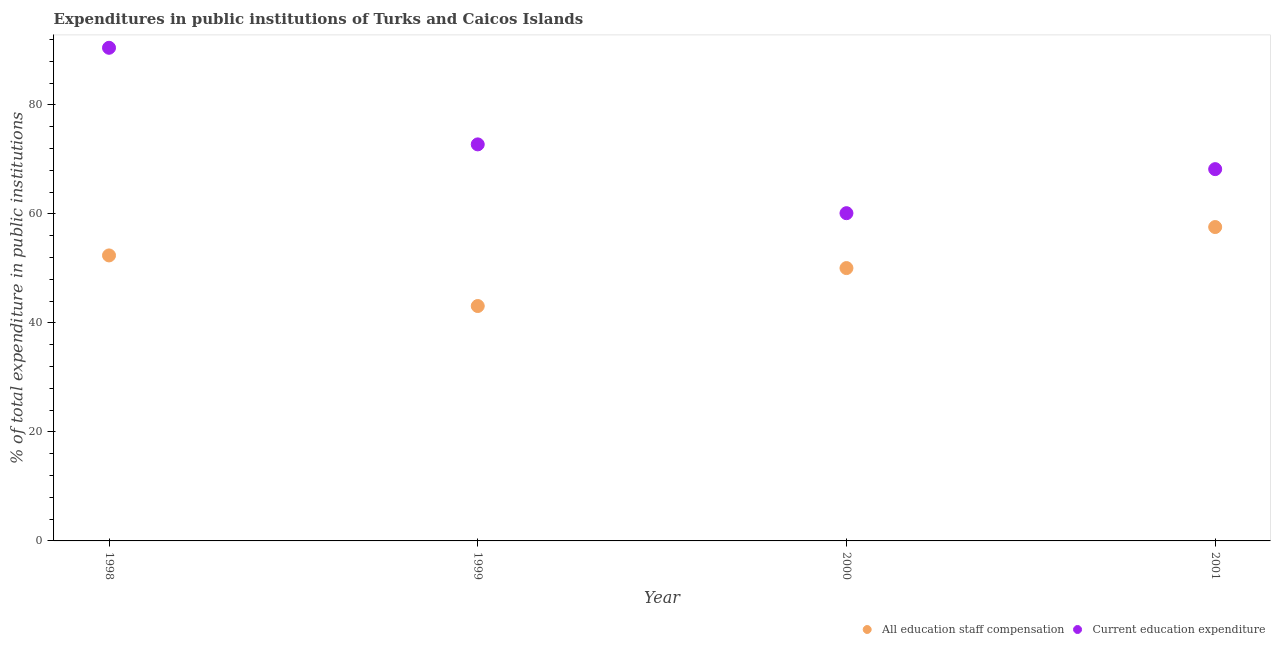What is the expenditure in education in 1998?
Offer a terse response. 90.48. Across all years, what is the maximum expenditure in education?
Make the answer very short. 90.48. Across all years, what is the minimum expenditure in education?
Keep it short and to the point. 60.13. In which year was the expenditure in staff compensation minimum?
Offer a terse response. 1999. What is the total expenditure in education in the graph?
Offer a terse response. 291.57. What is the difference between the expenditure in education in 1999 and that in 2001?
Offer a very short reply. 4.54. What is the difference between the expenditure in education in 1999 and the expenditure in staff compensation in 1998?
Give a very brief answer. 20.37. What is the average expenditure in staff compensation per year?
Your answer should be very brief. 50.78. In the year 1999, what is the difference between the expenditure in education and expenditure in staff compensation?
Give a very brief answer. 29.66. What is the ratio of the expenditure in education in 1998 to that in 1999?
Provide a succinct answer. 1.24. Is the difference between the expenditure in education in 2000 and 2001 greater than the difference between the expenditure in staff compensation in 2000 and 2001?
Your answer should be compact. No. What is the difference between the highest and the second highest expenditure in education?
Your answer should be compact. 17.72. What is the difference between the highest and the lowest expenditure in staff compensation?
Your answer should be compact. 14.49. Is the sum of the expenditure in staff compensation in 2000 and 2001 greater than the maximum expenditure in education across all years?
Provide a succinct answer. Yes. Is the expenditure in education strictly greater than the expenditure in staff compensation over the years?
Keep it short and to the point. Yes. What is the difference between two consecutive major ticks on the Y-axis?
Offer a very short reply. 20. Does the graph contain any zero values?
Keep it short and to the point. No. How many legend labels are there?
Offer a terse response. 2. How are the legend labels stacked?
Your answer should be compact. Horizontal. What is the title of the graph?
Your response must be concise. Expenditures in public institutions of Turks and Caicos Islands. What is the label or title of the X-axis?
Keep it short and to the point. Year. What is the label or title of the Y-axis?
Provide a succinct answer. % of total expenditure in public institutions. What is the % of total expenditure in public institutions of All education staff compensation in 1998?
Your answer should be very brief. 52.38. What is the % of total expenditure in public institutions of Current education expenditure in 1998?
Make the answer very short. 90.48. What is the % of total expenditure in public institutions of All education staff compensation in 1999?
Ensure brevity in your answer.  43.1. What is the % of total expenditure in public institutions in Current education expenditure in 1999?
Give a very brief answer. 72.75. What is the % of total expenditure in public institutions of All education staff compensation in 2000?
Provide a succinct answer. 50.06. What is the % of total expenditure in public institutions in Current education expenditure in 2000?
Give a very brief answer. 60.13. What is the % of total expenditure in public institutions in All education staff compensation in 2001?
Your response must be concise. 57.59. What is the % of total expenditure in public institutions of Current education expenditure in 2001?
Your answer should be very brief. 68.21. Across all years, what is the maximum % of total expenditure in public institutions in All education staff compensation?
Your response must be concise. 57.59. Across all years, what is the maximum % of total expenditure in public institutions of Current education expenditure?
Ensure brevity in your answer.  90.48. Across all years, what is the minimum % of total expenditure in public institutions in All education staff compensation?
Give a very brief answer. 43.1. Across all years, what is the minimum % of total expenditure in public institutions in Current education expenditure?
Offer a very short reply. 60.13. What is the total % of total expenditure in public institutions of All education staff compensation in the graph?
Your response must be concise. 203.12. What is the total % of total expenditure in public institutions of Current education expenditure in the graph?
Keep it short and to the point. 291.57. What is the difference between the % of total expenditure in public institutions in All education staff compensation in 1998 and that in 1999?
Ensure brevity in your answer.  9.28. What is the difference between the % of total expenditure in public institutions of Current education expenditure in 1998 and that in 1999?
Provide a succinct answer. 17.72. What is the difference between the % of total expenditure in public institutions of All education staff compensation in 1998 and that in 2000?
Make the answer very short. 2.32. What is the difference between the % of total expenditure in public institutions of Current education expenditure in 1998 and that in 2000?
Provide a short and direct response. 30.35. What is the difference between the % of total expenditure in public institutions of All education staff compensation in 1998 and that in 2001?
Offer a terse response. -5.21. What is the difference between the % of total expenditure in public institutions in Current education expenditure in 1998 and that in 2001?
Make the answer very short. 22.26. What is the difference between the % of total expenditure in public institutions of All education staff compensation in 1999 and that in 2000?
Your answer should be compact. -6.96. What is the difference between the % of total expenditure in public institutions of Current education expenditure in 1999 and that in 2000?
Keep it short and to the point. 12.62. What is the difference between the % of total expenditure in public institutions of All education staff compensation in 1999 and that in 2001?
Ensure brevity in your answer.  -14.49. What is the difference between the % of total expenditure in public institutions of Current education expenditure in 1999 and that in 2001?
Ensure brevity in your answer.  4.54. What is the difference between the % of total expenditure in public institutions of All education staff compensation in 2000 and that in 2001?
Make the answer very short. -7.53. What is the difference between the % of total expenditure in public institutions of Current education expenditure in 2000 and that in 2001?
Make the answer very short. -8.08. What is the difference between the % of total expenditure in public institutions in All education staff compensation in 1998 and the % of total expenditure in public institutions in Current education expenditure in 1999?
Give a very brief answer. -20.37. What is the difference between the % of total expenditure in public institutions of All education staff compensation in 1998 and the % of total expenditure in public institutions of Current education expenditure in 2000?
Provide a short and direct response. -7.75. What is the difference between the % of total expenditure in public institutions of All education staff compensation in 1998 and the % of total expenditure in public institutions of Current education expenditure in 2001?
Provide a short and direct response. -15.83. What is the difference between the % of total expenditure in public institutions of All education staff compensation in 1999 and the % of total expenditure in public institutions of Current education expenditure in 2000?
Provide a short and direct response. -17.03. What is the difference between the % of total expenditure in public institutions in All education staff compensation in 1999 and the % of total expenditure in public institutions in Current education expenditure in 2001?
Your answer should be very brief. -25.12. What is the difference between the % of total expenditure in public institutions of All education staff compensation in 2000 and the % of total expenditure in public institutions of Current education expenditure in 2001?
Keep it short and to the point. -18.15. What is the average % of total expenditure in public institutions in All education staff compensation per year?
Give a very brief answer. 50.78. What is the average % of total expenditure in public institutions in Current education expenditure per year?
Your response must be concise. 72.89. In the year 1998, what is the difference between the % of total expenditure in public institutions in All education staff compensation and % of total expenditure in public institutions in Current education expenditure?
Make the answer very short. -38.1. In the year 1999, what is the difference between the % of total expenditure in public institutions in All education staff compensation and % of total expenditure in public institutions in Current education expenditure?
Your answer should be very brief. -29.66. In the year 2000, what is the difference between the % of total expenditure in public institutions of All education staff compensation and % of total expenditure in public institutions of Current education expenditure?
Your answer should be very brief. -10.07. In the year 2001, what is the difference between the % of total expenditure in public institutions of All education staff compensation and % of total expenditure in public institutions of Current education expenditure?
Make the answer very short. -10.63. What is the ratio of the % of total expenditure in public institutions of All education staff compensation in 1998 to that in 1999?
Give a very brief answer. 1.22. What is the ratio of the % of total expenditure in public institutions in Current education expenditure in 1998 to that in 1999?
Your answer should be compact. 1.24. What is the ratio of the % of total expenditure in public institutions in All education staff compensation in 1998 to that in 2000?
Your answer should be very brief. 1.05. What is the ratio of the % of total expenditure in public institutions in Current education expenditure in 1998 to that in 2000?
Your response must be concise. 1.5. What is the ratio of the % of total expenditure in public institutions of All education staff compensation in 1998 to that in 2001?
Your response must be concise. 0.91. What is the ratio of the % of total expenditure in public institutions in Current education expenditure in 1998 to that in 2001?
Provide a succinct answer. 1.33. What is the ratio of the % of total expenditure in public institutions in All education staff compensation in 1999 to that in 2000?
Make the answer very short. 0.86. What is the ratio of the % of total expenditure in public institutions in Current education expenditure in 1999 to that in 2000?
Offer a very short reply. 1.21. What is the ratio of the % of total expenditure in public institutions of All education staff compensation in 1999 to that in 2001?
Offer a terse response. 0.75. What is the ratio of the % of total expenditure in public institutions in Current education expenditure in 1999 to that in 2001?
Your answer should be compact. 1.07. What is the ratio of the % of total expenditure in public institutions of All education staff compensation in 2000 to that in 2001?
Give a very brief answer. 0.87. What is the ratio of the % of total expenditure in public institutions of Current education expenditure in 2000 to that in 2001?
Your response must be concise. 0.88. What is the difference between the highest and the second highest % of total expenditure in public institutions in All education staff compensation?
Offer a terse response. 5.21. What is the difference between the highest and the second highest % of total expenditure in public institutions in Current education expenditure?
Your answer should be very brief. 17.72. What is the difference between the highest and the lowest % of total expenditure in public institutions in All education staff compensation?
Provide a succinct answer. 14.49. What is the difference between the highest and the lowest % of total expenditure in public institutions in Current education expenditure?
Offer a very short reply. 30.35. 